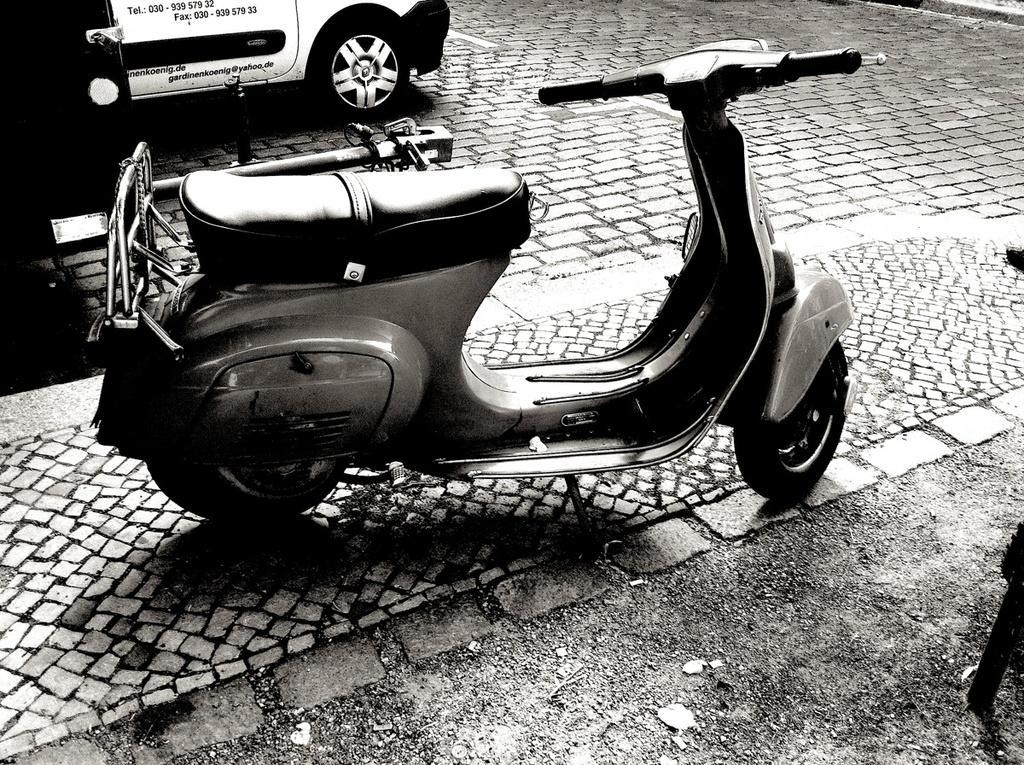Could you give a brief overview of what you see in this image? This is a black and white image, in this image there is a scooter and a car on a pavement. 